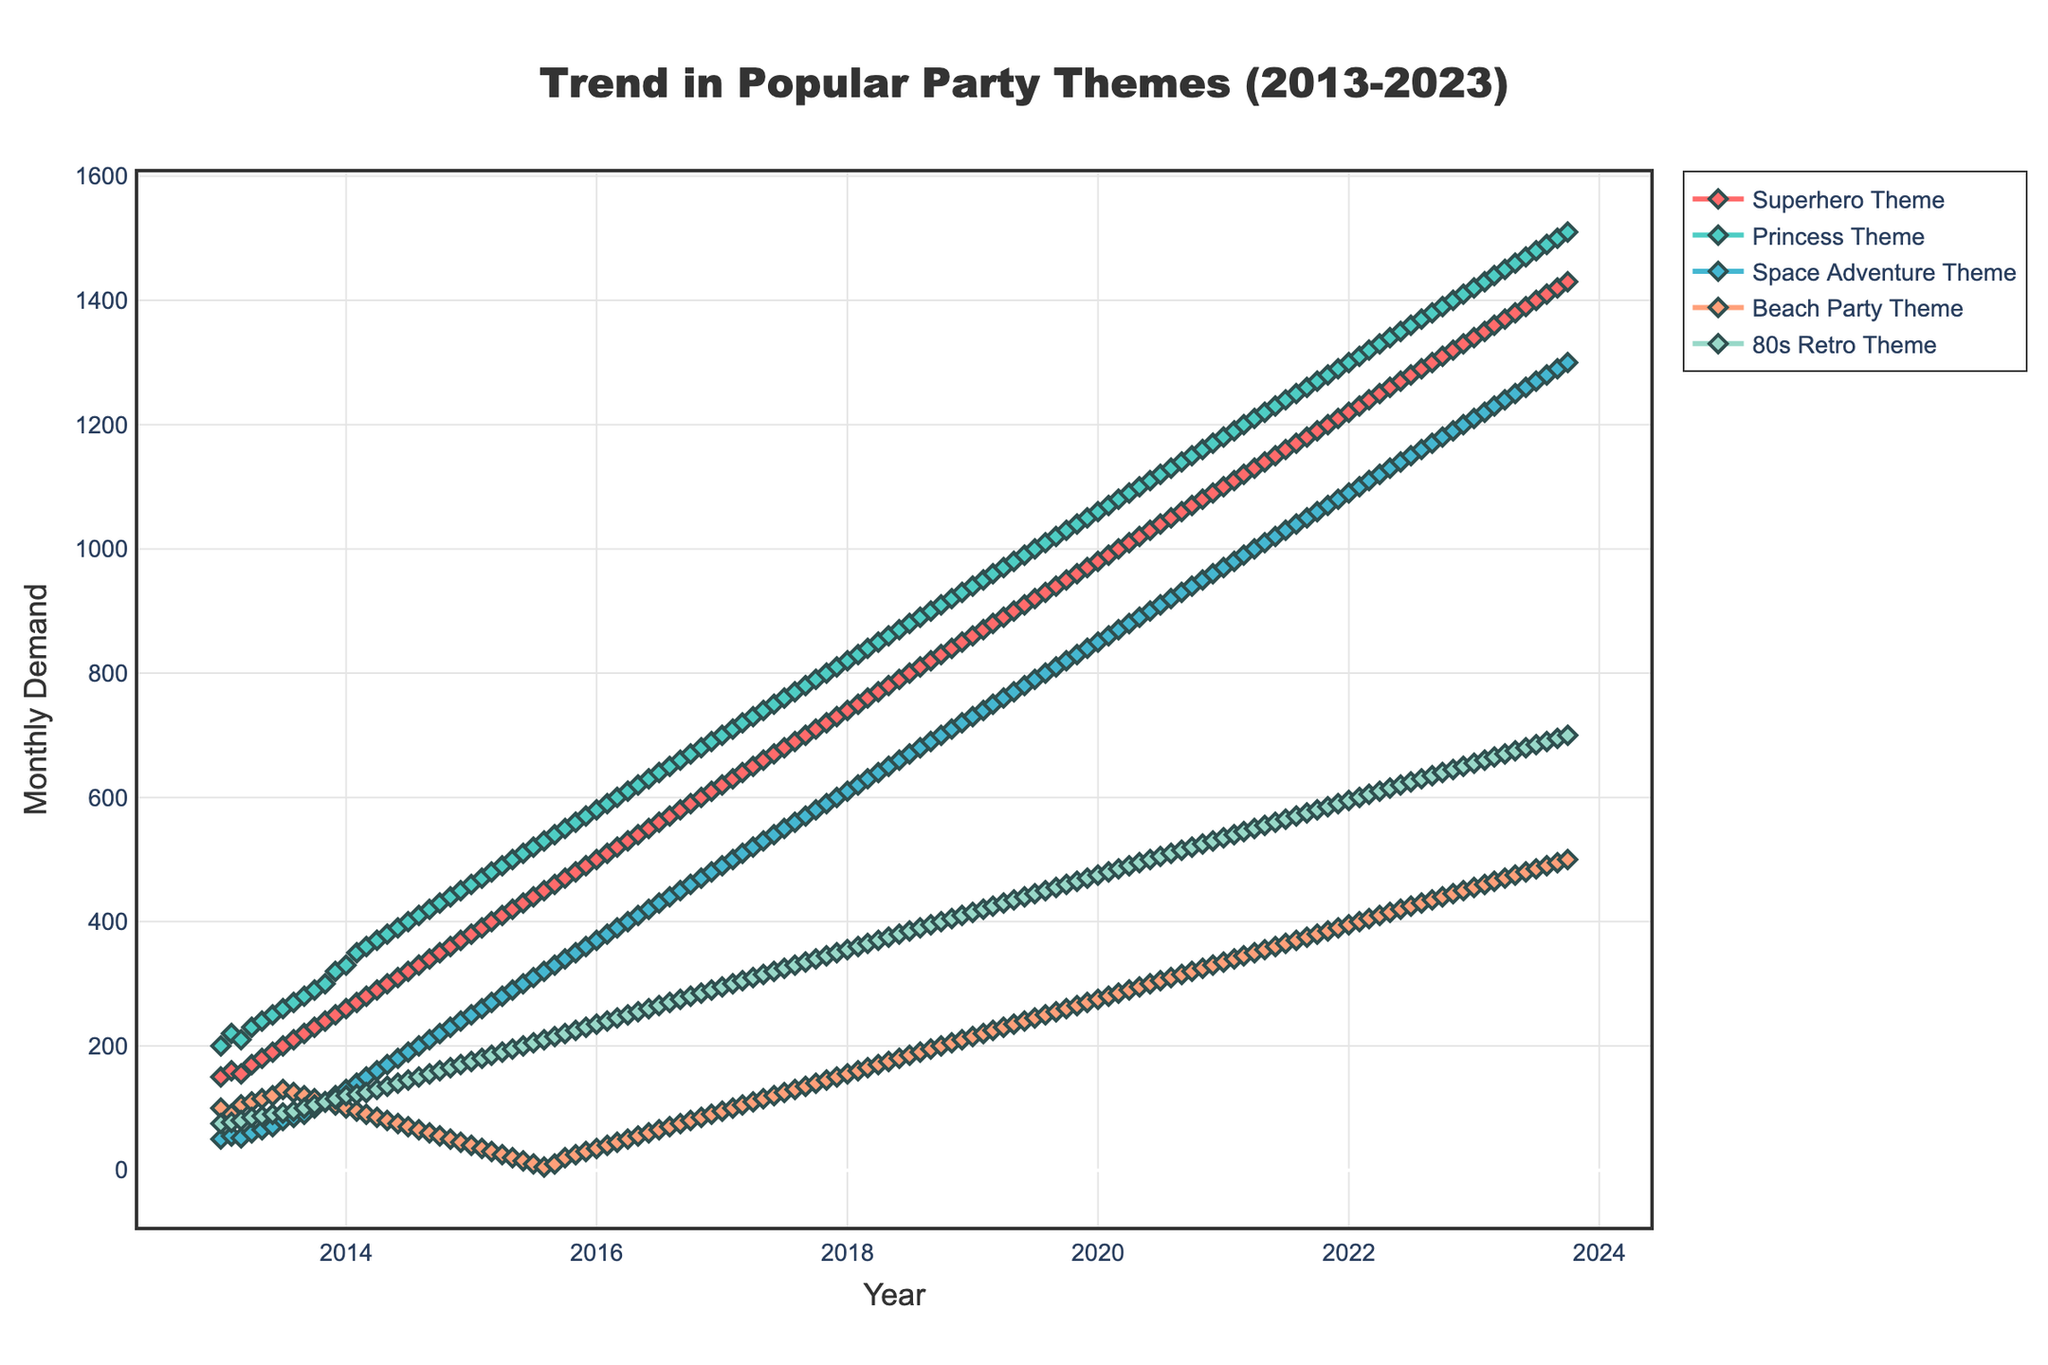What is the title of the plot? The title is generally displayed at the top of the figure. For this plot, it's prominently shown in the center above the axes.
Answer: "Trend in Popular Party Themes (2013-2023)" Which theme had the highest demand in October 2023? To find the highest demand theme in October 2023, look at the end of the x-axis where the years are specified and locate October 2023. Check the y-values of each theme for this month. The highest y-value represents the theme with the highest demand.
Answer: "Princess Theme" How does the demand for the "80s Retro Theme" in January 2015 compare to January 2020? Locate January 2015 and January 2020 on the x-axis, and compare the y-values for the "80s Retro Theme."
Answer: The demand increased from 175 to 475 What is the main trend observed for the "Space Adventure Theme" over the decade? Observe the plotted line for the "Space Adventure Theme" from the beginning to the end of the plot to determine the general trend.
Answer: Increasing trend By how much did the demand for the "Beach Party Theme" change from July 2017 to July 2021? Locate July 2017 and July 2021 on the x-axis and check the y-values for the "Beach Party Theme." Calculate the difference between the two values: 365 (July 2021) - 125 (July 2017) = 240.
Answer: 240 Which theme had the least demand in December 2019? Locate December 2019 on the x-axis and look at the y-values of each theme. The theme with the lowest y-value has the least demand.
Answer: "Beach Party Theme" How many themes have a demand exceeding 1000 units by the end of the dataset in October 2023? At the far right end of the x-axis, check each theme's y-value for October 2023. Count how many of these values are above 1000.
Answer: Five themes Which theme displayed a sudden drop in demand in the year 2015? Examine the year 2015 across all themes and look for a significant downward spike in any of the plotted lines.
Answer: "Beach Party Theme" Is there any recurring seasonal pattern observable in any theme's demand? Review the yearly fluctuations in each theme's line to see if any themes show a repeating pattern over the years.
Answer: No clear seasonal pattern displayed 